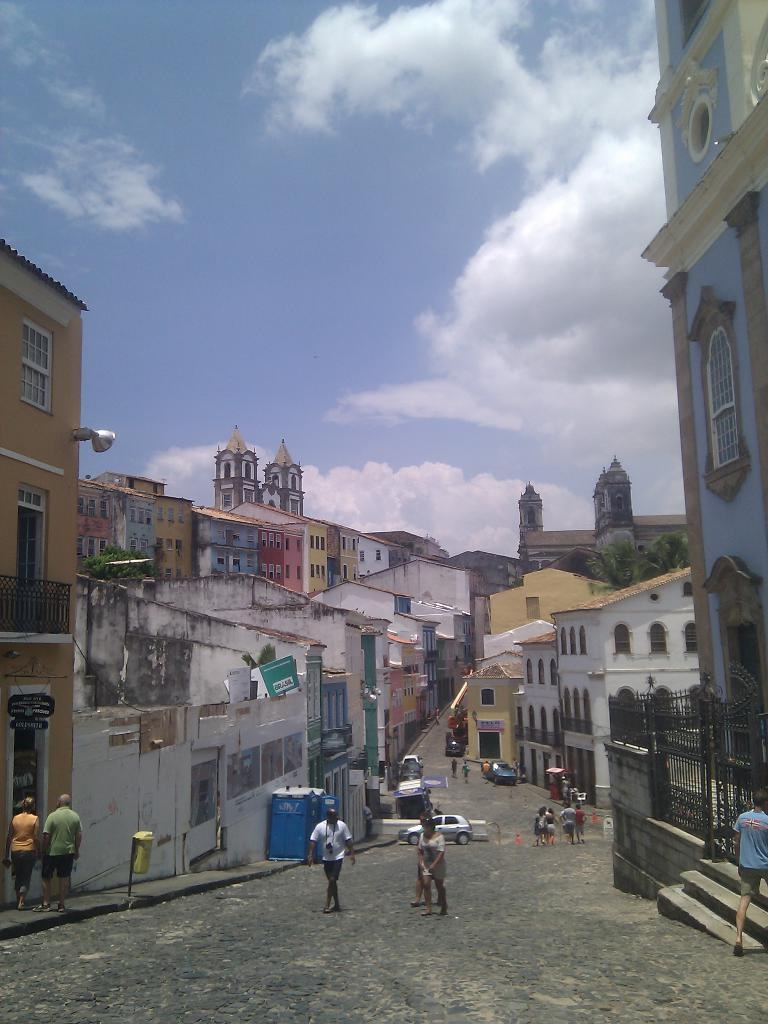What type of structures can be seen in the image? There are buildings in the image. Are there any living beings present in the image? Yes, there are people in the image. What mode of transportation can be seen on the road in the image? There are vehicles on the road in the image. What type of container is present in the image? There is a bin in the image. What color is the object mentioned in the image? There is a blue color object in the image. What can be seen in the sky in the image? There are clouds in the sky in the image. Where is the crowd gathered in the image? There is no crowd mentioned or visible in the image. What type of appliance is used for cooking in the image? There is no oven or cooking appliance present in the image. 